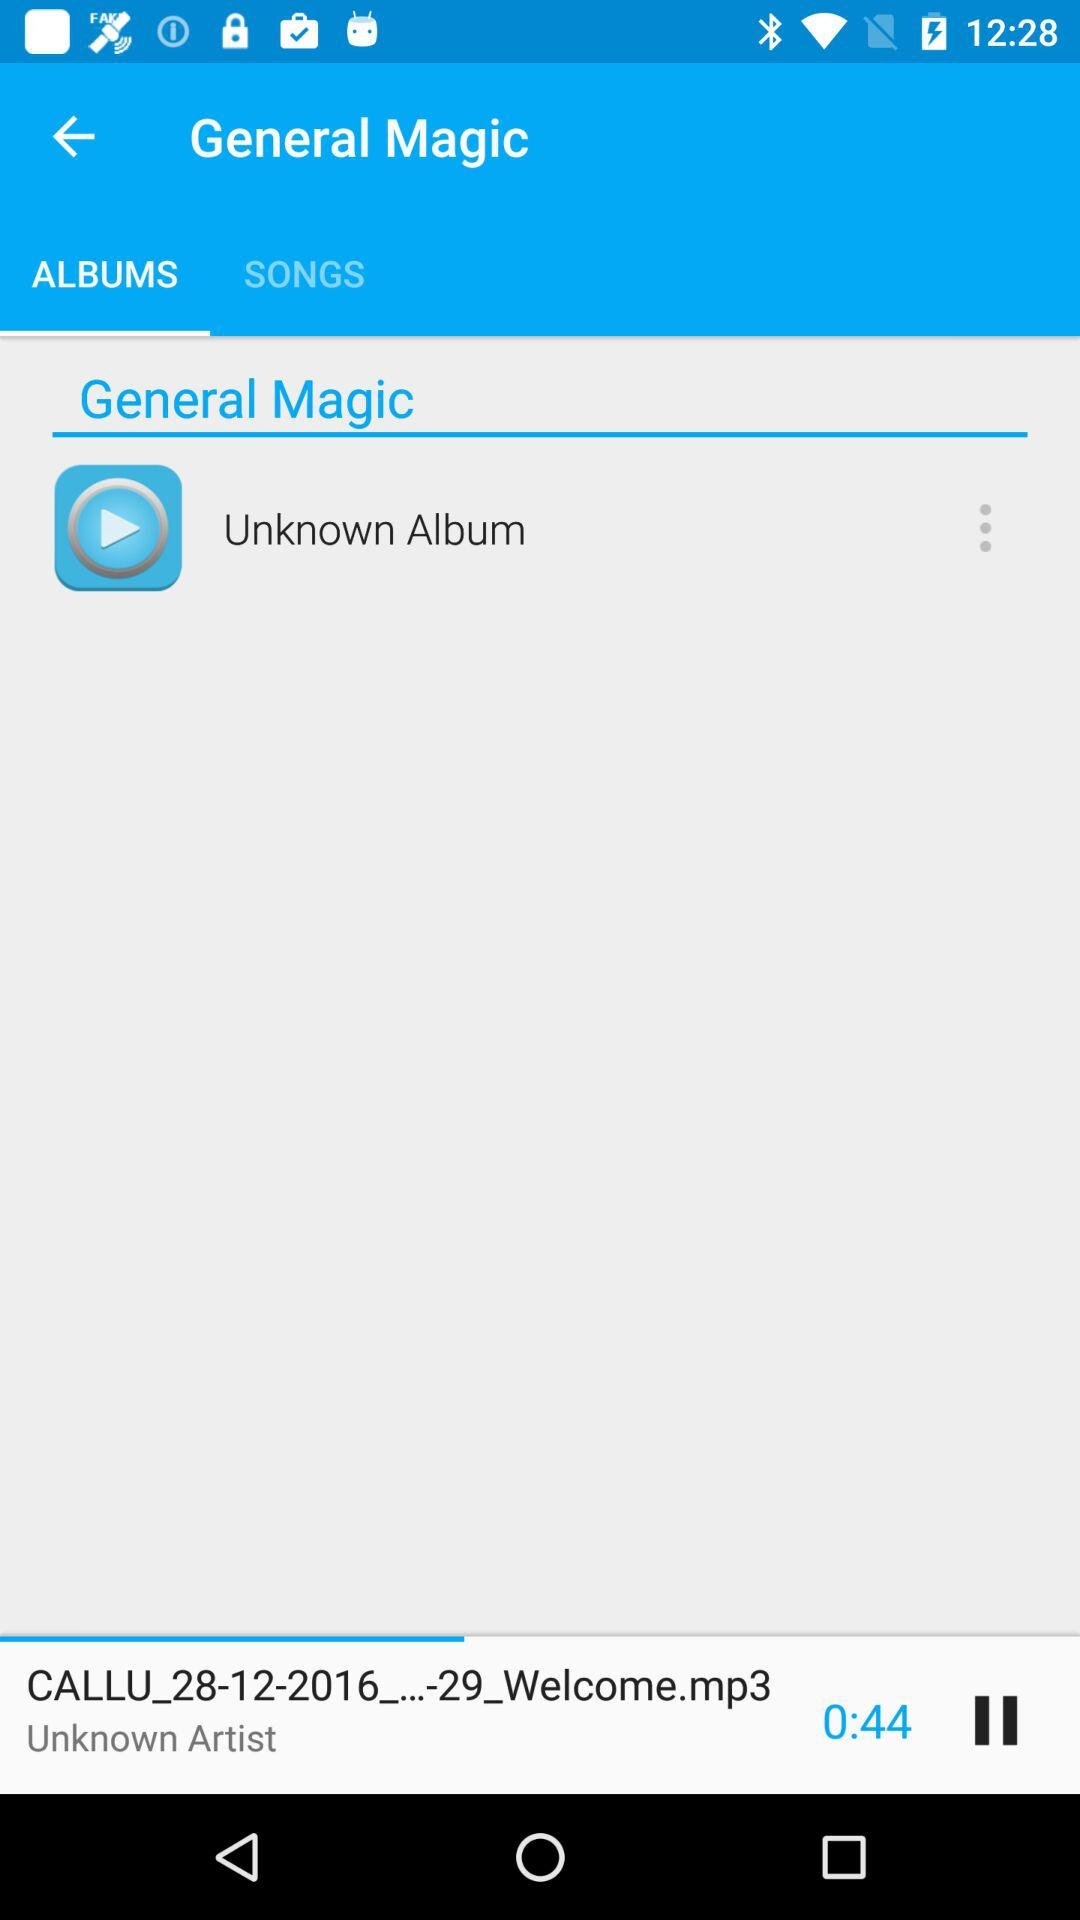Which tab has been selected? The tab that has been selected is "ALBUMS". 